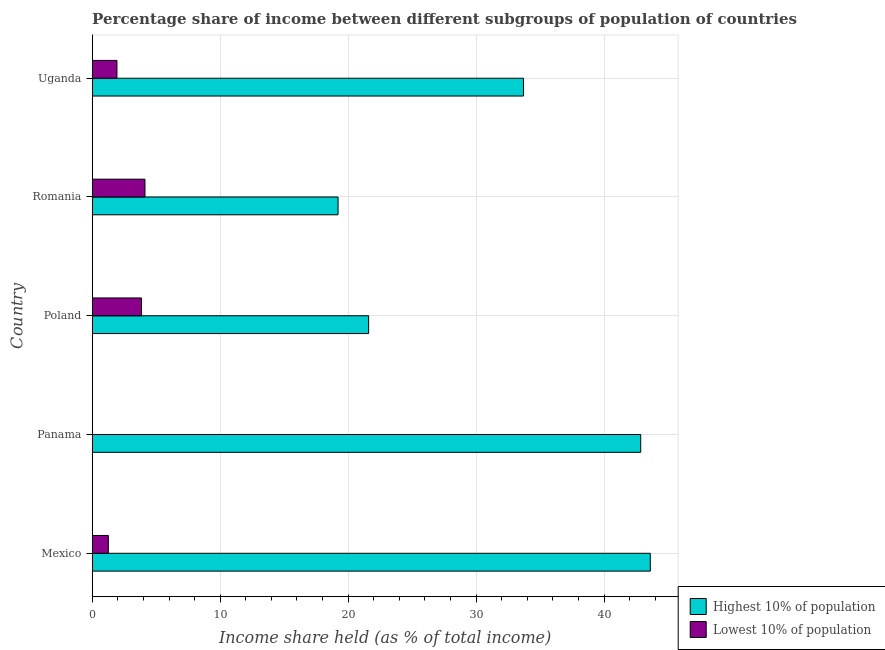How many groups of bars are there?
Provide a succinct answer. 5. Are the number of bars per tick equal to the number of legend labels?
Your answer should be compact. Yes. Are the number of bars on each tick of the Y-axis equal?
Keep it short and to the point. Yes. How many bars are there on the 4th tick from the top?
Your answer should be very brief. 2. How many bars are there on the 5th tick from the bottom?
Offer a terse response. 2. What is the label of the 4th group of bars from the top?
Your answer should be very brief. Panama. In how many cases, is the number of bars for a given country not equal to the number of legend labels?
Your answer should be compact. 0. What is the income share held by lowest 10% of the population in Mexico?
Ensure brevity in your answer.  1.26. Across all countries, what is the maximum income share held by highest 10% of the population?
Your response must be concise. 43.61. Across all countries, what is the minimum income share held by highest 10% of the population?
Keep it short and to the point. 19.21. In which country was the income share held by lowest 10% of the population maximum?
Your answer should be very brief. Romania. In which country was the income share held by lowest 10% of the population minimum?
Ensure brevity in your answer.  Panama. What is the total income share held by lowest 10% of the population in the graph?
Your answer should be compact. 11.18. What is the difference between the income share held by lowest 10% of the population in Panama and that in Uganda?
Provide a short and direct response. -1.91. What is the difference between the income share held by highest 10% of the population in Mexico and the income share held by lowest 10% of the population in Poland?
Your response must be concise. 39.76. What is the average income share held by lowest 10% of the population per country?
Ensure brevity in your answer.  2.24. What is the difference between the income share held by lowest 10% of the population and income share held by highest 10% of the population in Panama?
Ensure brevity in your answer.  -42.84. What is the ratio of the income share held by highest 10% of the population in Poland to that in Uganda?
Provide a short and direct response. 0.64. Is the income share held by lowest 10% of the population in Panama less than that in Poland?
Make the answer very short. Yes. Is the difference between the income share held by highest 10% of the population in Mexico and Uganda greater than the difference between the income share held by lowest 10% of the population in Mexico and Uganda?
Your response must be concise. Yes. In how many countries, is the income share held by lowest 10% of the population greater than the average income share held by lowest 10% of the population taken over all countries?
Provide a short and direct response. 2. Is the sum of the income share held by highest 10% of the population in Poland and Uganda greater than the maximum income share held by lowest 10% of the population across all countries?
Offer a very short reply. Yes. What does the 1st bar from the top in Poland represents?
Keep it short and to the point. Lowest 10% of population. What does the 2nd bar from the bottom in Poland represents?
Give a very brief answer. Lowest 10% of population. How many bars are there?
Provide a succinct answer. 10. Are all the bars in the graph horizontal?
Your answer should be very brief. Yes. How many countries are there in the graph?
Provide a short and direct response. 5. What is the difference between two consecutive major ticks on the X-axis?
Give a very brief answer. 10. Are the values on the major ticks of X-axis written in scientific E-notation?
Offer a very short reply. No. What is the title of the graph?
Ensure brevity in your answer.  Percentage share of income between different subgroups of population of countries. Does "Working only" appear as one of the legend labels in the graph?
Give a very brief answer. No. What is the label or title of the X-axis?
Give a very brief answer. Income share held (as % of total income). What is the label or title of the Y-axis?
Provide a short and direct response. Country. What is the Income share held (as % of total income) in Highest 10% of population in Mexico?
Ensure brevity in your answer.  43.61. What is the Income share held (as % of total income) in Lowest 10% of population in Mexico?
Provide a succinct answer. 1.26. What is the Income share held (as % of total income) of Highest 10% of population in Panama?
Ensure brevity in your answer.  42.86. What is the Income share held (as % of total income) of Highest 10% of population in Poland?
Offer a very short reply. 21.6. What is the Income share held (as % of total income) in Lowest 10% of population in Poland?
Offer a terse response. 3.85. What is the Income share held (as % of total income) in Highest 10% of population in Romania?
Provide a short and direct response. 19.21. What is the Income share held (as % of total income) in Lowest 10% of population in Romania?
Ensure brevity in your answer.  4.12. What is the Income share held (as % of total income) in Highest 10% of population in Uganda?
Your response must be concise. 33.7. What is the Income share held (as % of total income) of Lowest 10% of population in Uganda?
Give a very brief answer. 1.93. Across all countries, what is the maximum Income share held (as % of total income) of Highest 10% of population?
Make the answer very short. 43.61. Across all countries, what is the maximum Income share held (as % of total income) of Lowest 10% of population?
Your response must be concise. 4.12. Across all countries, what is the minimum Income share held (as % of total income) in Highest 10% of population?
Your answer should be very brief. 19.21. Across all countries, what is the minimum Income share held (as % of total income) in Lowest 10% of population?
Offer a very short reply. 0.02. What is the total Income share held (as % of total income) of Highest 10% of population in the graph?
Keep it short and to the point. 160.98. What is the total Income share held (as % of total income) of Lowest 10% of population in the graph?
Keep it short and to the point. 11.18. What is the difference between the Income share held (as % of total income) of Highest 10% of population in Mexico and that in Panama?
Provide a short and direct response. 0.75. What is the difference between the Income share held (as % of total income) in Lowest 10% of population in Mexico and that in Panama?
Offer a very short reply. 1.24. What is the difference between the Income share held (as % of total income) in Highest 10% of population in Mexico and that in Poland?
Give a very brief answer. 22.01. What is the difference between the Income share held (as % of total income) of Lowest 10% of population in Mexico and that in Poland?
Offer a terse response. -2.59. What is the difference between the Income share held (as % of total income) in Highest 10% of population in Mexico and that in Romania?
Your answer should be compact. 24.4. What is the difference between the Income share held (as % of total income) in Lowest 10% of population in Mexico and that in Romania?
Give a very brief answer. -2.86. What is the difference between the Income share held (as % of total income) of Highest 10% of population in Mexico and that in Uganda?
Keep it short and to the point. 9.91. What is the difference between the Income share held (as % of total income) of Lowest 10% of population in Mexico and that in Uganda?
Your answer should be compact. -0.67. What is the difference between the Income share held (as % of total income) of Highest 10% of population in Panama and that in Poland?
Keep it short and to the point. 21.26. What is the difference between the Income share held (as % of total income) of Lowest 10% of population in Panama and that in Poland?
Offer a very short reply. -3.83. What is the difference between the Income share held (as % of total income) in Highest 10% of population in Panama and that in Romania?
Offer a very short reply. 23.65. What is the difference between the Income share held (as % of total income) of Lowest 10% of population in Panama and that in Romania?
Your answer should be compact. -4.1. What is the difference between the Income share held (as % of total income) in Highest 10% of population in Panama and that in Uganda?
Offer a very short reply. 9.16. What is the difference between the Income share held (as % of total income) of Lowest 10% of population in Panama and that in Uganda?
Give a very brief answer. -1.91. What is the difference between the Income share held (as % of total income) in Highest 10% of population in Poland and that in Romania?
Provide a short and direct response. 2.39. What is the difference between the Income share held (as % of total income) of Lowest 10% of population in Poland and that in Romania?
Offer a very short reply. -0.27. What is the difference between the Income share held (as % of total income) in Lowest 10% of population in Poland and that in Uganda?
Your response must be concise. 1.92. What is the difference between the Income share held (as % of total income) of Highest 10% of population in Romania and that in Uganda?
Your answer should be compact. -14.49. What is the difference between the Income share held (as % of total income) in Lowest 10% of population in Romania and that in Uganda?
Your answer should be compact. 2.19. What is the difference between the Income share held (as % of total income) in Highest 10% of population in Mexico and the Income share held (as % of total income) in Lowest 10% of population in Panama?
Provide a succinct answer. 43.59. What is the difference between the Income share held (as % of total income) of Highest 10% of population in Mexico and the Income share held (as % of total income) of Lowest 10% of population in Poland?
Offer a terse response. 39.76. What is the difference between the Income share held (as % of total income) of Highest 10% of population in Mexico and the Income share held (as % of total income) of Lowest 10% of population in Romania?
Your response must be concise. 39.49. What is the difference between the Income share held (as % of total income) in Highest 10% of population in Mexico and the Income share held (as % of total income) in Lowest 10% of population in Uganda?
Offer a very short reply. 41.68. What is the difference between the Income share held (as % of total income) of Highest 10% of population in Panama and the Income share held (as % of total income) of Lowest 10% of population in Poland?
Your answer should be very brief. 39.01. What is the difference between the Income share held (as % of total income) in Highest 10% of population in Panama and the Income share held (as % of total income) in Lowest 10% of population in Romania?
Provide a succinct answer. 38.74. What is the difference between the Income share held (as % of total income) of Highest 10% of population in Panama and the Income share held (as % of total income) of Lowest 10% of population in Uganda?
Make the answer very short. 40.93. What is the difference between the Income share held (as % of total income) of Highest 10% of population in Poland and the Income share held (as % of total income) of Lowest 10% of population in Romania?
Your answer should be compact. 17.48. What is the difference between the Income share held (as % of total income) of Highest 10% of population in Poland and the Income share held (as % of total income) of Lowest 10% of population in Uganda?
Make the answer very short. 19.67. What is the difference between the Income share held (as % of total income) of Highest 10% of population in Romania and the Income share held (as % of total income) of Lowest 10% of population in Uganda?
Give a very brief answer. 17.28. What is the average Income share held (as % of total income) of Highest 10% of population per country?
Your answer should be compact. 32.2. What is the average Income share held (as % of total income) of Lowest 10% of population per country?
Make the answer very short. 2.24. What is the difference between the Income share held (as % of total income) in Highest 10% of population and Income share held (as % of total income) in Lowest 10% of population in Mexico?
Your answer should be compact. 42.35. What is the difference between the Income share held (as % of total income) of Highest 10% of population and Income share held (as % of total income) of Lowest 10% of population in Panama?
Ensure brevity in your answer.  42.84. What is the difference between the Income share held (as % of total income) in Highest 10% of population and Income share held (as % of total income) in Lowest 10% of population in Poland?
Keep it short and to the point. 17.75. What is the difference between the Income share held (as % of total income) in Highest 10% of population and Income share held (as % of total income) in Lowest 10% of population in Romania?
Provide a short and direct response. 15.09. What is the difference between the Income share held (as % of total income) of Highest 10% of population and Income share held (as % of total income) of Lowest 10% of population in Uganda?
Your response must be concise. 31.77. What is the ratio of the Income share held (as % of total income) in Highest 10% of population in Mexico to that in Panama?
Keep it short and to the point. 1.02. What is the ratio of the Income share held (as % of total income) in Highest 10% of population in Mexico to that in Poland?
Provide a short and direct response. 2.02. What is the ratio of the Income share held (as % of total income) in Lowest 10% of population in Mexico to that in Poland?
Provide a succinct answer. 0.33. What is the ratio of the Income share held (as % of total income) of Highest 10% of population in Mexico to that in Romania?
Your answer should be compact. 2.27. What is the ratio of the Income share held (as % of total income) of Lowest 10% of population in Mexico to that in Romania?
Your response must be concise. 0.31. What is the ratio of the Income share held (as % of total income) in Highest 10% of population in Mexico to that in Uganda?
Keep it short and to the point. 1.29. What is the ratio of the Income share held (as % of total income) in Lowest 10% of population in Mexico to that in Uganda?
Ensure brevity in your answer.  0.65. What is the ratio of the Income share held (as % of total income) of Highest 10% of population in Panama to that in Poland?
Offer a very short reply. 1.98. What is the ratio of the Income share held (as % of total income) of Lowest 10% of population in Panama to that in Poland?
Your answer should be very brief. 0.01. What is the ratio of the Income share held (as % of total income) in Highest 10% of population in Panama to that in Romania?
Offer a terse response. 2.23. What is the ratio of the Income share held (as % of total income) of Lowest 10% of population in Panama to that in Romania?
Provide a short and direct response. 0. What is the ratio of the Income share held (as % of total income) in Highest 10% of population in Panama to that in Uganda?
Offer a terse response. 1.27. What is the ratio of the Income share held (as % of total income) of Lowest 10% of population in Panama to that in Uganda?
Your response must be concise. 0.01. What is the ratio of the Income share held (as % of total income) of Highest 10% of population in Poland to that in Romania?
Your response must be concise. 1.12. What is the ratio of the Income share held (as % of total income) of Lowest 10% of population in Poland to that in Romania?
Your answer should be compact. 0.93. What is the ratio of the Income share held (as % of total income) in Highest 10% of population in Poland to that in Uganda?
Offer a very short reply. 0.64. What is the ratio of the Income share held (as % of total income) of Lowest 10% of population in Poland to that in Uganda?
Give a very brief answer. 1.99. What is the ratio of the Income share held (as % of total income) of Highest 10% of population in Romania to that in Uganda?
Provide a short and direct response. 0.57. What is the ratio of the Income share held (as % of total income) of Lowest 10% of population in Romania to that in Uganda?
Ensure brevity in your answer.  2.13. What is the difference between the highest and the second highest Income share held (as % of total income) of Lowest 10% of population?
Provide a succinct answer. 0.27. What is the difference between the highest and the lowest Income share held (as % of total income) of Highest 10% of population?
Offer a terse response. 24.4. 